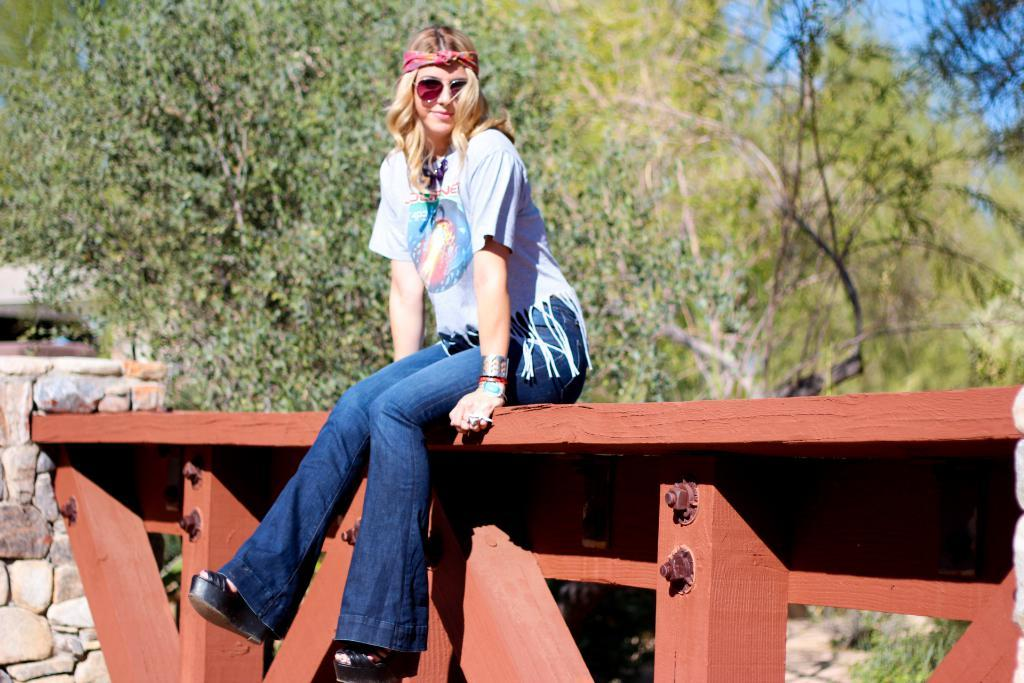Who is the main subject in the image? There is a woman in the middle of the image. What is located at the bottom of the image? There are wooden planks at the bottom of the image. What type of hardware can be seen in the image? Nuts and bolts are present in the image. Can you tell me how many horses are visible in the image? There are no horses present in the image. What type of seat is the woman sitting on in the image? The provided facts do not mention a seat or any furniture in the image. 